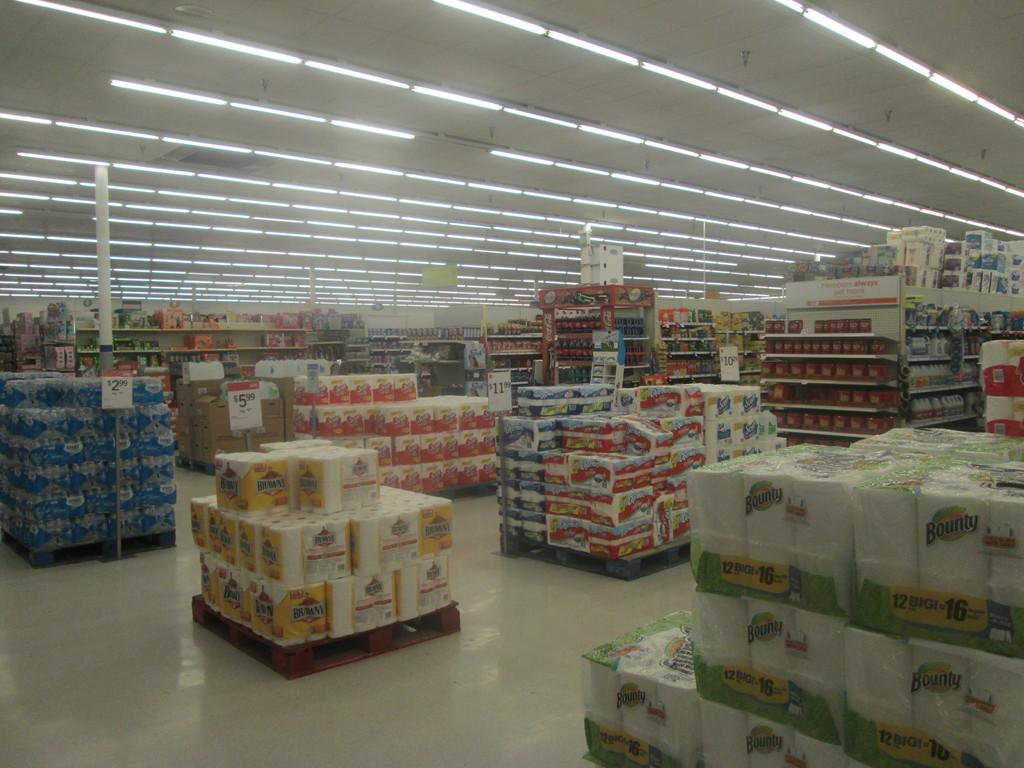<image>
Render a clear and concise summary of the photo. Displays in a store including Bounty and Brawny paper towels. 